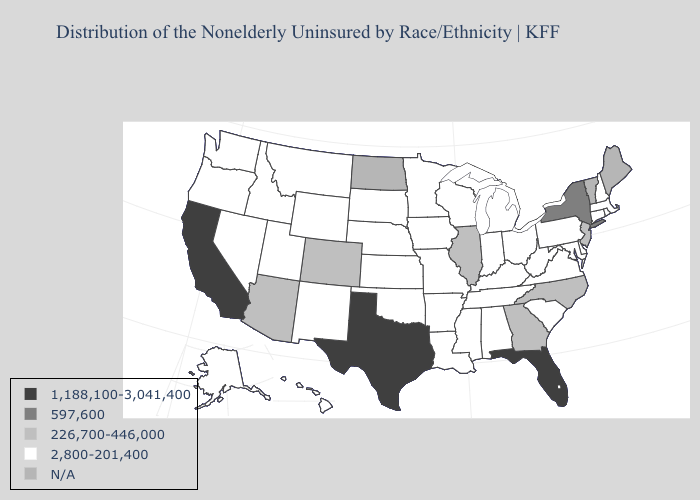Name the states that have a value in the range 226,700-446,000?
Quick response, please. Arizona, Colorado, Georgia, Illinois, New Jersey, North Carolina. What is the value of Idaho?
Short answer required. 2,800-201,400. What is the highest value in states that border Wyoming?
Be succinct. 226,700-446,000. Does California have the lowest value in the West?
Be succinct. No. Does Texas have the highest value in the USA?
Answer briefly. Yes. Name the states that have a value in the range 226,700-446,000?
Short answer required. Arizona, Colorado, Georgia, Illinois, New Jersey, North Carolina. What is the value of New Hampshire?
Write a very short answer. 2,800-201,400. Does Rhode Island have the lowest value in the Northeast?
Concise answer only. Yes. Name the states that have a value in the range 1,188,100-3,041,400?
Quick response, please. California, Florida, Texas. Name the states that have a value in the range 1,188,100-3,041,400?
Answer briefly. California, Florida, Texas. Does the map have missing data?
Be succinct. Yes. What is the value of South Carolina?
Write a very short answer. 2,800-201,400. What is the value of Mississippi?
Quick response, please. 2,800-201,400. 